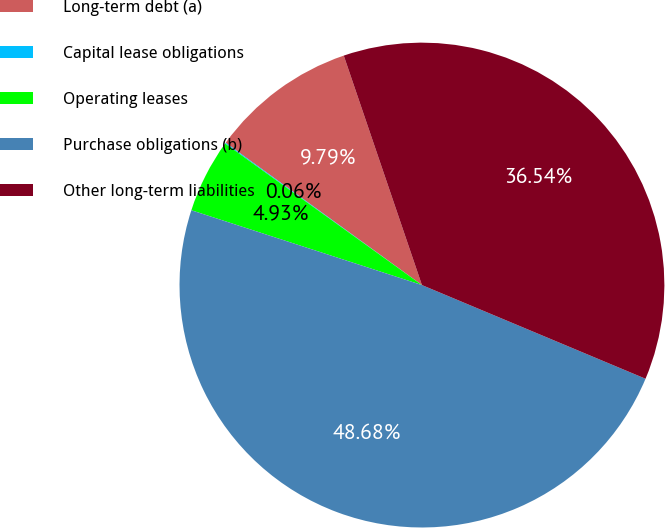Convert chart to OTSL. <chart><loc_0><loc_0><loc_500><loc_500><pie_chart><fcel>Long-term debt (a)<fcel>Capital lease obligations<fcel>Operating leases<fcel>Purchase obligations (b)<fcel>Other long-term liabilities<nl><fcel>9.79%<fcel>0.06%<fcel>4.93%<fcel>48.68%<fcel>36.54%<nl></chart> 